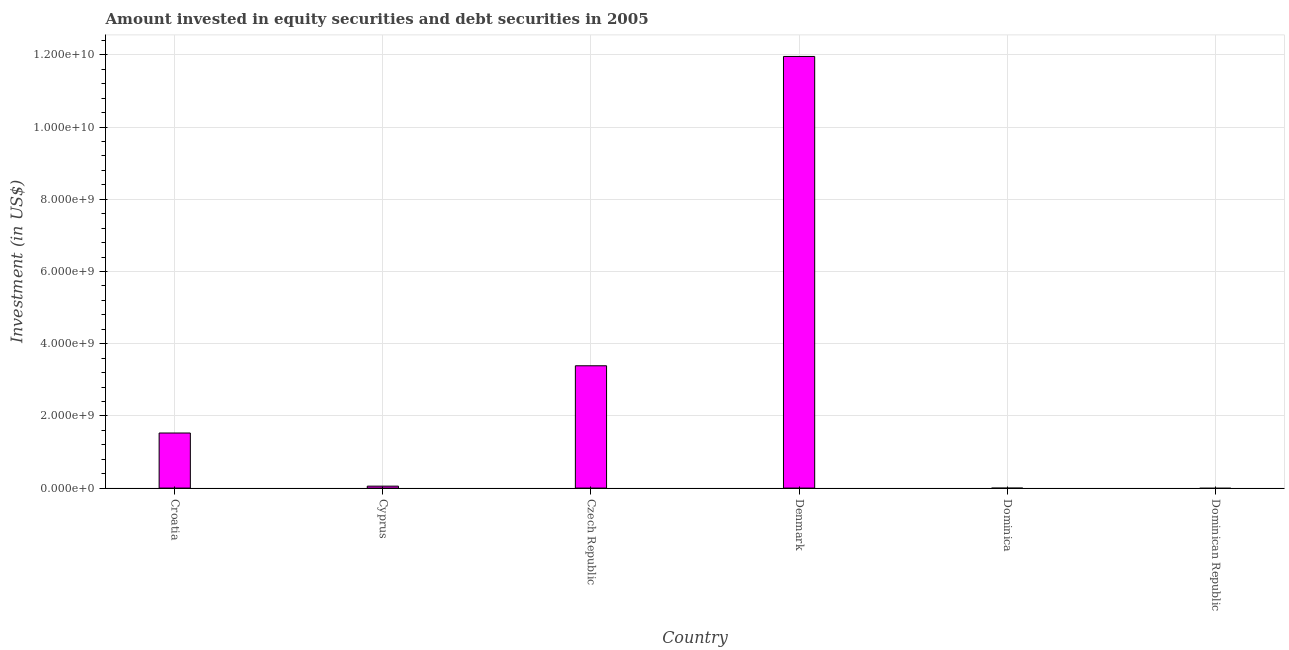What is the title of the graph?
Offer a terse response. Amount invested in equity securities and debt securities in 2005. What is the label or title of the Y-axis?
Offer a very short reply. Investment (in US$). What is the portfolio investment in Denmark?
Offer a terse response. 1.20e+1. Across all countries, what is the maximum portfolio investment?
Provide a succinct answer. 1.20e+1. Across all countries, what is the minimum portfolio investment?
Keep it short and to the point. 0. In which country was the portfolio investment maximum?
Your answer should be compact. Denmark. What is the sum of the portfolio investment?
Offer a very short reply. 1.69e+1. What is the difference between the portfolio investment in Croatia and Czech Republic?
Your response must be concise. -1.86e+09. What is the average portfolio investment per country?
Provide a succinct answer. 2.82e+09. What is the median portfolio investment?
Provide a succinct answer. 7.90e+08. What is the ratio of the portfolio investment in Croatia to that in Czech Republic?
Provide a short and direct response. 0.45. What is the difference between the highest and the second highest portfolio investment?
Give a very brief answer. 8.57e+09. Is the sum of the portfolio investment in Cyprus and Czech Republic greater than the maximum portfolio investment across all countries?
Offer a terse response. No. What is the difference between the highest and the lowest portfolio investment?
Ensure brevity in your answer.  1.20e+1. In how many countries, is the portfolio investment greater than the average portfolio investment taken over all countries?
Your answer should be very brief. 2. Are all the bars in the graph horizontal?
Keep it short and to the point. No. What is the difference between two consecutive major ticks on the Y-axis?
Keep it short and to the point. 2.00e+09. Are the values on the major ticks of Y-axis written in scientific E-notation?
Keep it short and to the point. Yes. What is the Investment (in US$) in Croatia?
Offer a very short reply. 1.53e+09. What is the Investment (in US$) in Cyprus?
Give a very brief answer. 5.37e+07. What is the Investment (in US$) of Czech Republic?
Your answer should be compact. 3.39e+09. What is the Investment (in US$) in Denmark?
Your answer should be very brief. 1.20e+1. What is the difference between the Investment (in US$) in Croatia and Cyprus?
Ensure brevity in your answer.  1.47e+09. What is the difference between the Investment (in US$) in Croatia and Czech Republic?
Your response must be concise. -1.86e+09. What is the difference between the Investment (in US$) in Croatia and Denmark?
Offer a very short reply. -1.04e+1. What is the difference between the Investment (in US$) in Cyprus and Czech Republic?
Your response must be concise. -3.33e+09. What is the difference between the Investment (in US$) in Cyprus and Denmark?
Make the answer very short. -1.19e+1. What is the difference between the Investment (in US$) in Czech Republic and Denmark?
Offer a terse response. -8.57e+09. What is the ratio of the Investment (in US$) in Croatia to that in Cyprus?
Your answer should be very brief. 28.39. What is the ratio of the Investment (in US$) in Croatia to that in Czech Republic?
Provide a short and direct response. 0.45. What is the ratio of the Investment (in US$) in Croatia to that in Denmark?
Your answer should be very brief. 0.13. What is the ratio of the Investment (in US$) in Cyprus to that in Czech Republic?
Provide a succinct answer. 0.02. What is the ratio of the Investment (in US$) in Cyprus to that in Denmark?
Offer a terse response. 0. What is the ratio of the Investment (in US$) in Czech Republic to that in Denmark?
Make the answer very short. 0.28. 